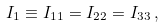Convert formula to latex. <formula><loc_0><loc_0><loc_500><loc_500>I _ { 1 } \equiv I _ { 1 1 } = I _ { 2 2 } = I _ { 3 3 } \, ,</formula> 